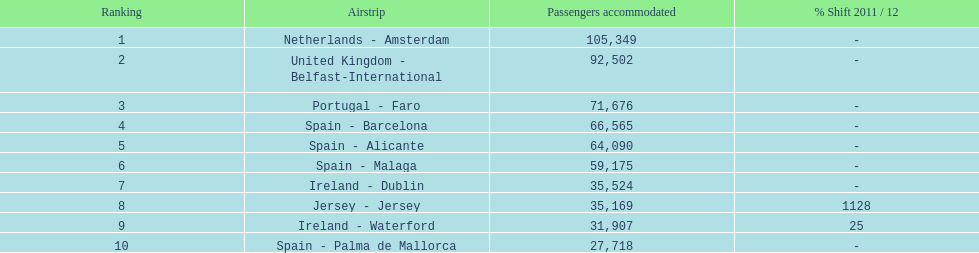What is the name of the only airport in portugal that is among the 10 busiest routes to and from london southend airport in 2012? Portugal - Faro. 